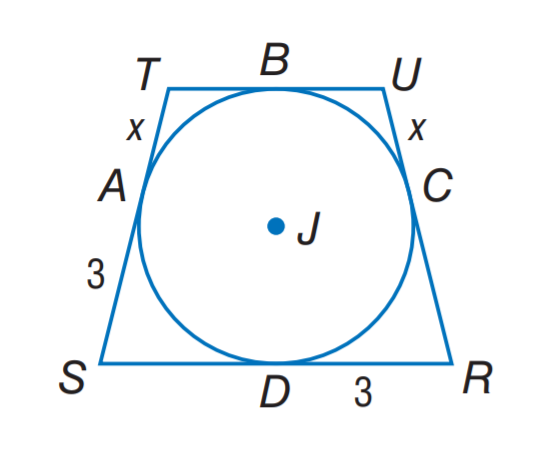Question: Quadrilateral R S T U is circumscribed about \odot J. If the preimeter is 18 units, find x.
Choices:
A. 1
B. 1.5
C. 3
D. 4.5
Answer with the letter. Answer: B 